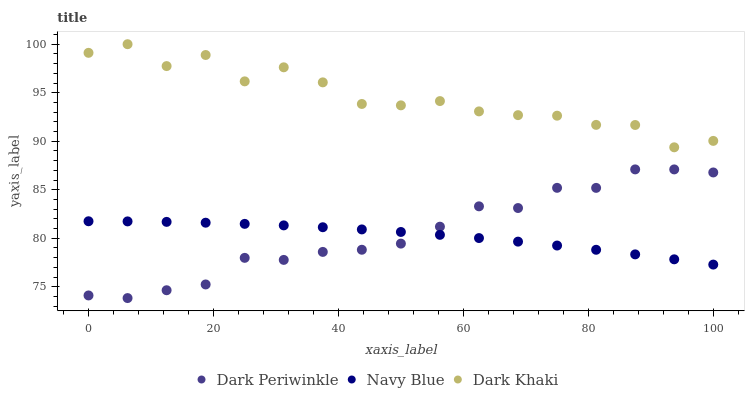Does Navy Blue have the minimum area under the curve?
Answer yes or no. Yes. Does Dark Khaki have the maximum area under the curve?
Answer yes or no. Yes. Does Dark Periwinkle have the minimum area under the curve?
Answer yes or no. No. Does Dark Periwinkle have the maximum area under the curve?
Answer yes or no. No. Is Navy Blue the smoothest?
Answer yes or no. Yes. Is Dark Khaki the roughest?
Answer yes or no. Yes. Is Dark Periwinkle the smoothest?
Answer yes or no. No. Is Dark Periwinkle the roughest?
Answer yes or no. No. Does Dark Periwinkle have the lowest value?
Answer yes or no. Yes. Does Navy Blue have the lowest value?
Answer yes or no. No. Does Dark Khaki have the highest value?
Answer yes or no. Yes. Does Dark Periwinkle have the highest value?
Answer yes or no. No. Is Navy Blue less than Dark Khaki?
Answer yes or no. Yes. Is Dark Khaki greater than Navy Blue?
Answer yes or no. Yes. Does Dark Periwinkle intersect Navy Blue?
Answer yes or no. Yes. Is Dark Periwinkle less than Navy Blue?
Answer yes or no. No. Is Dark Periwinkle greater than Navy Blue?
Answer yes or no. No. Does Navy Blue intersect Dark Khaki?
Answer yes or no. No. 